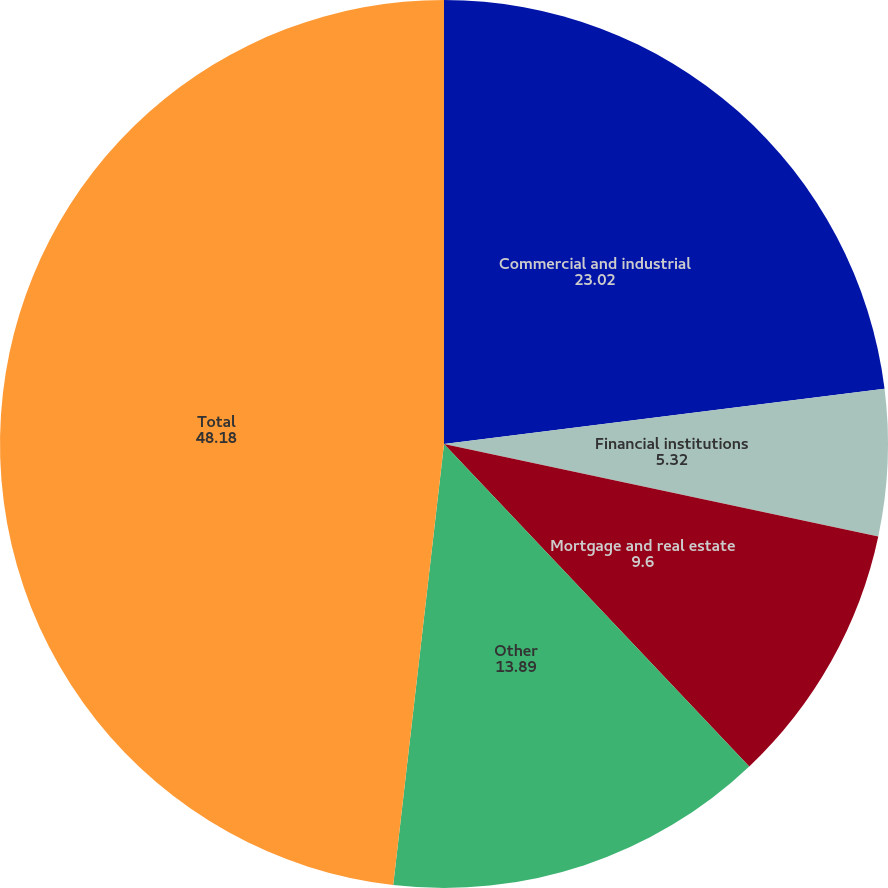<chart> <loc_0><loc_0><loc_500><loc_500><pie_chart><fcel>Commercial and industrial<fcel>Financial institutions<fcel>Mortgage and real estate<fcel>Other<fcel>Total<nl><fcel>23.02%<fcel>5.32%<fcel>9.6%<fcel>13.89%<fcel>48.18%<nl></chart> 